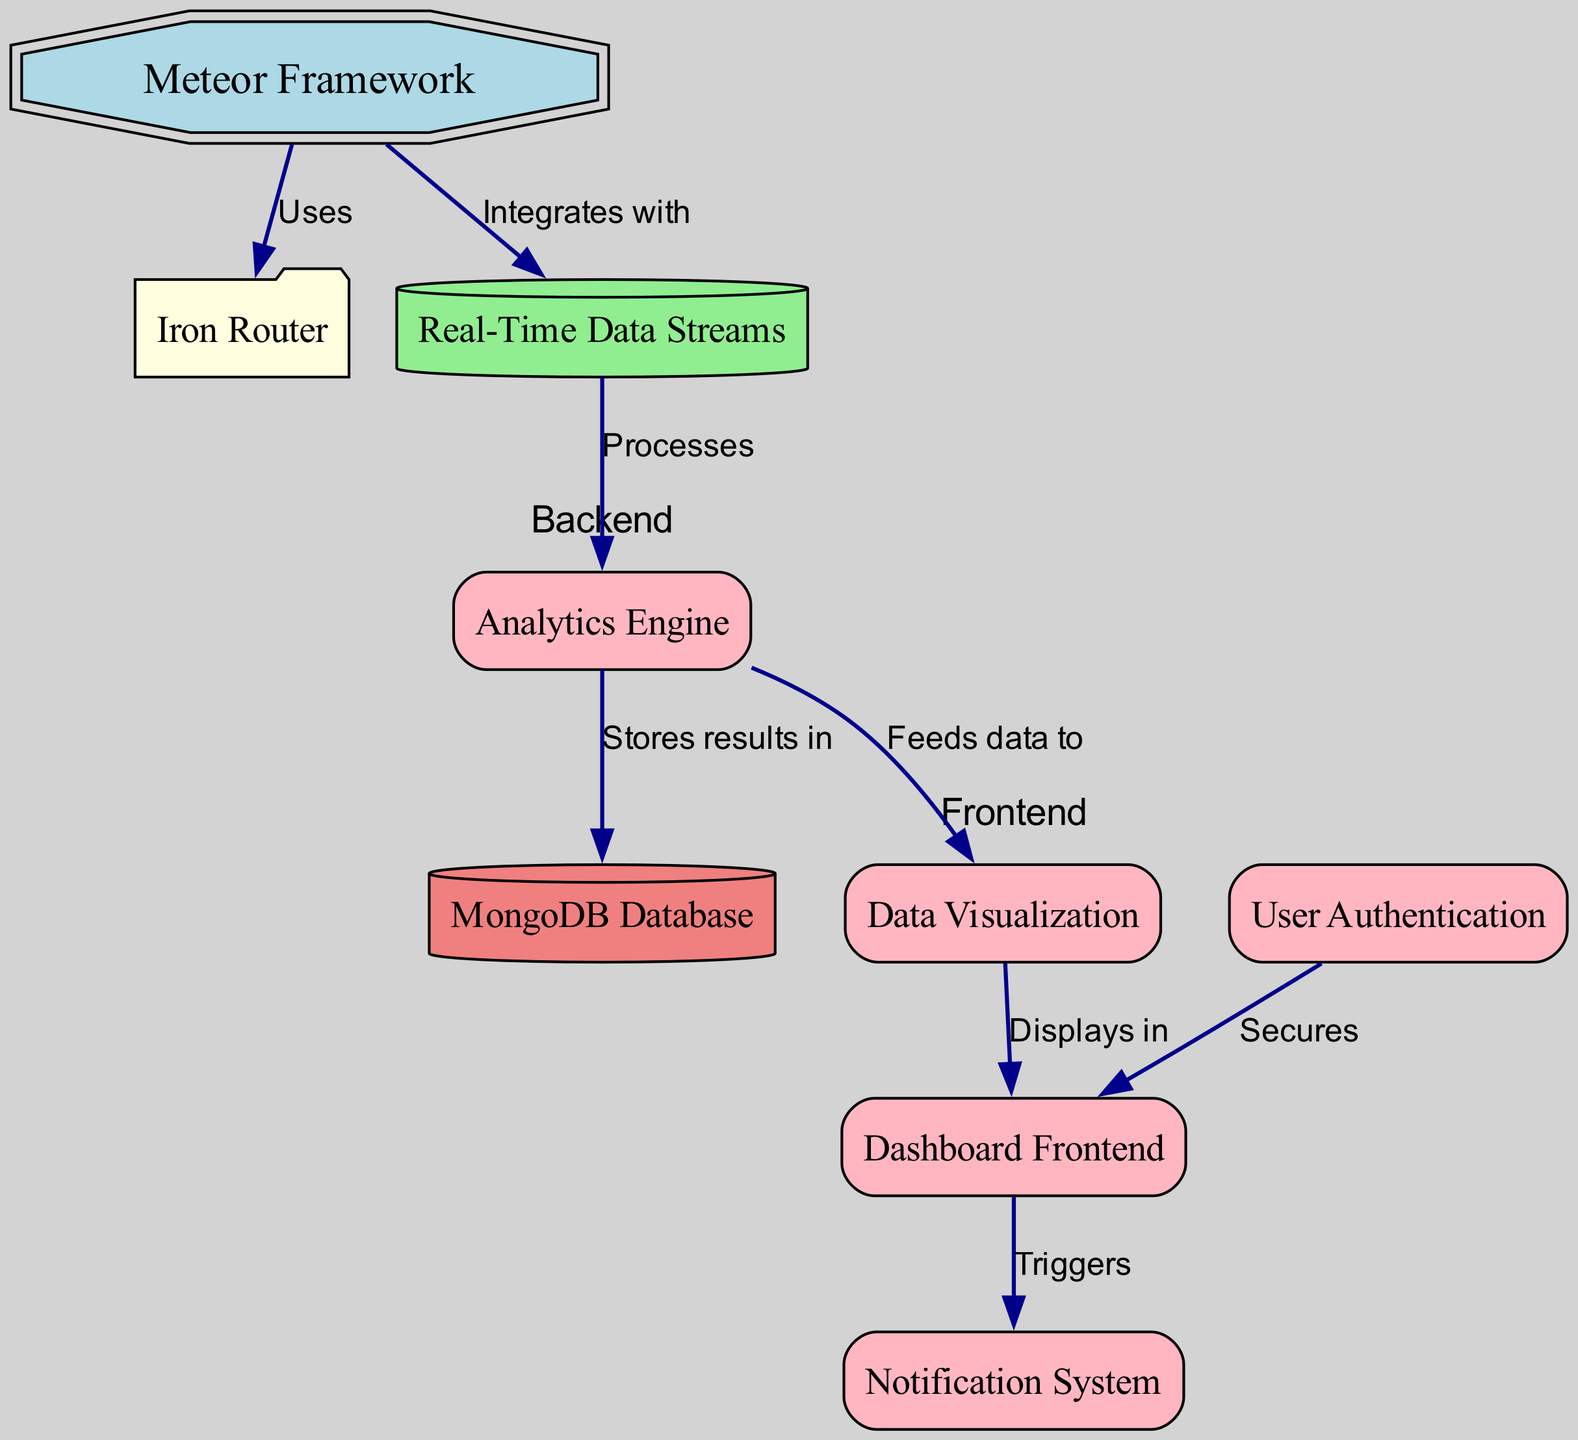What is the main framework used in the diagram? The diagram shows the node labeled "Meteor Framework" as the primary structure, indicating that Meteor is the main framework utilized in the system design.
Answer: Meteor Framework How many components are there in this diagram? The diagram lists several nodes categorized as components, which are the Analytics Engine, Data Visualization, User Authentication, Dashboard Frontend, and Notification System. Thus, there are five components identified in total.
Answer: 5 What type of data does the Analytics Engine process? The diagram indicates that the Analytics Engine node processes "Real-Time Data Streams" as depicted by the edge connecting Real-Time Data to the Analytics Engine.
Answer: Real-Time Data Streams Which component secures the dashboard frontend? The diagram includes an edge from the "User Authentication" node to the "Dashboard Frontend" node, indicating that User Authentication is responsible for securing the Dashboard Frontend.
Answer: User Authentication What does the Data Visualization component display data in? The arrow leading from the Data Visualization component to the Dashboard Frontend explicitly indicates that the Data Visualization feeds data to be displayed in the Dashboard Frontend.
Answer: Dashboard Frontend How many edges are connecting the Analytics Engine? There are two edges connecting the Analytics Engine: one to the Data Visualization and one to the MongoDB Database. This shows that the Analytics Engine is linked to multiple components, showcasing its central role in the design.
Answer: 2 What does the Notification System do in relation to the Dashboard Frontend? The diagram shows that the Dashboard Frontend triggers the Notification System, indicating that the Dashboard Frontend is responsible for initiating notifications.
Answer: Triggers Which database is used to store results? The diagram denotes a connection from the Analytics Engine to the MongoDB Database, indicating that MongoDB is utilized for storing the results processed by the Analytics Engine.
Answer: MongoDB Database How does the framework interact with the Iron Router? The connection indicated by the edge from the Meteor node to the Iron Router node shows that the Meteor framework uses the Iron Router as part of its routing strategy in the application.
Answer: Uses 